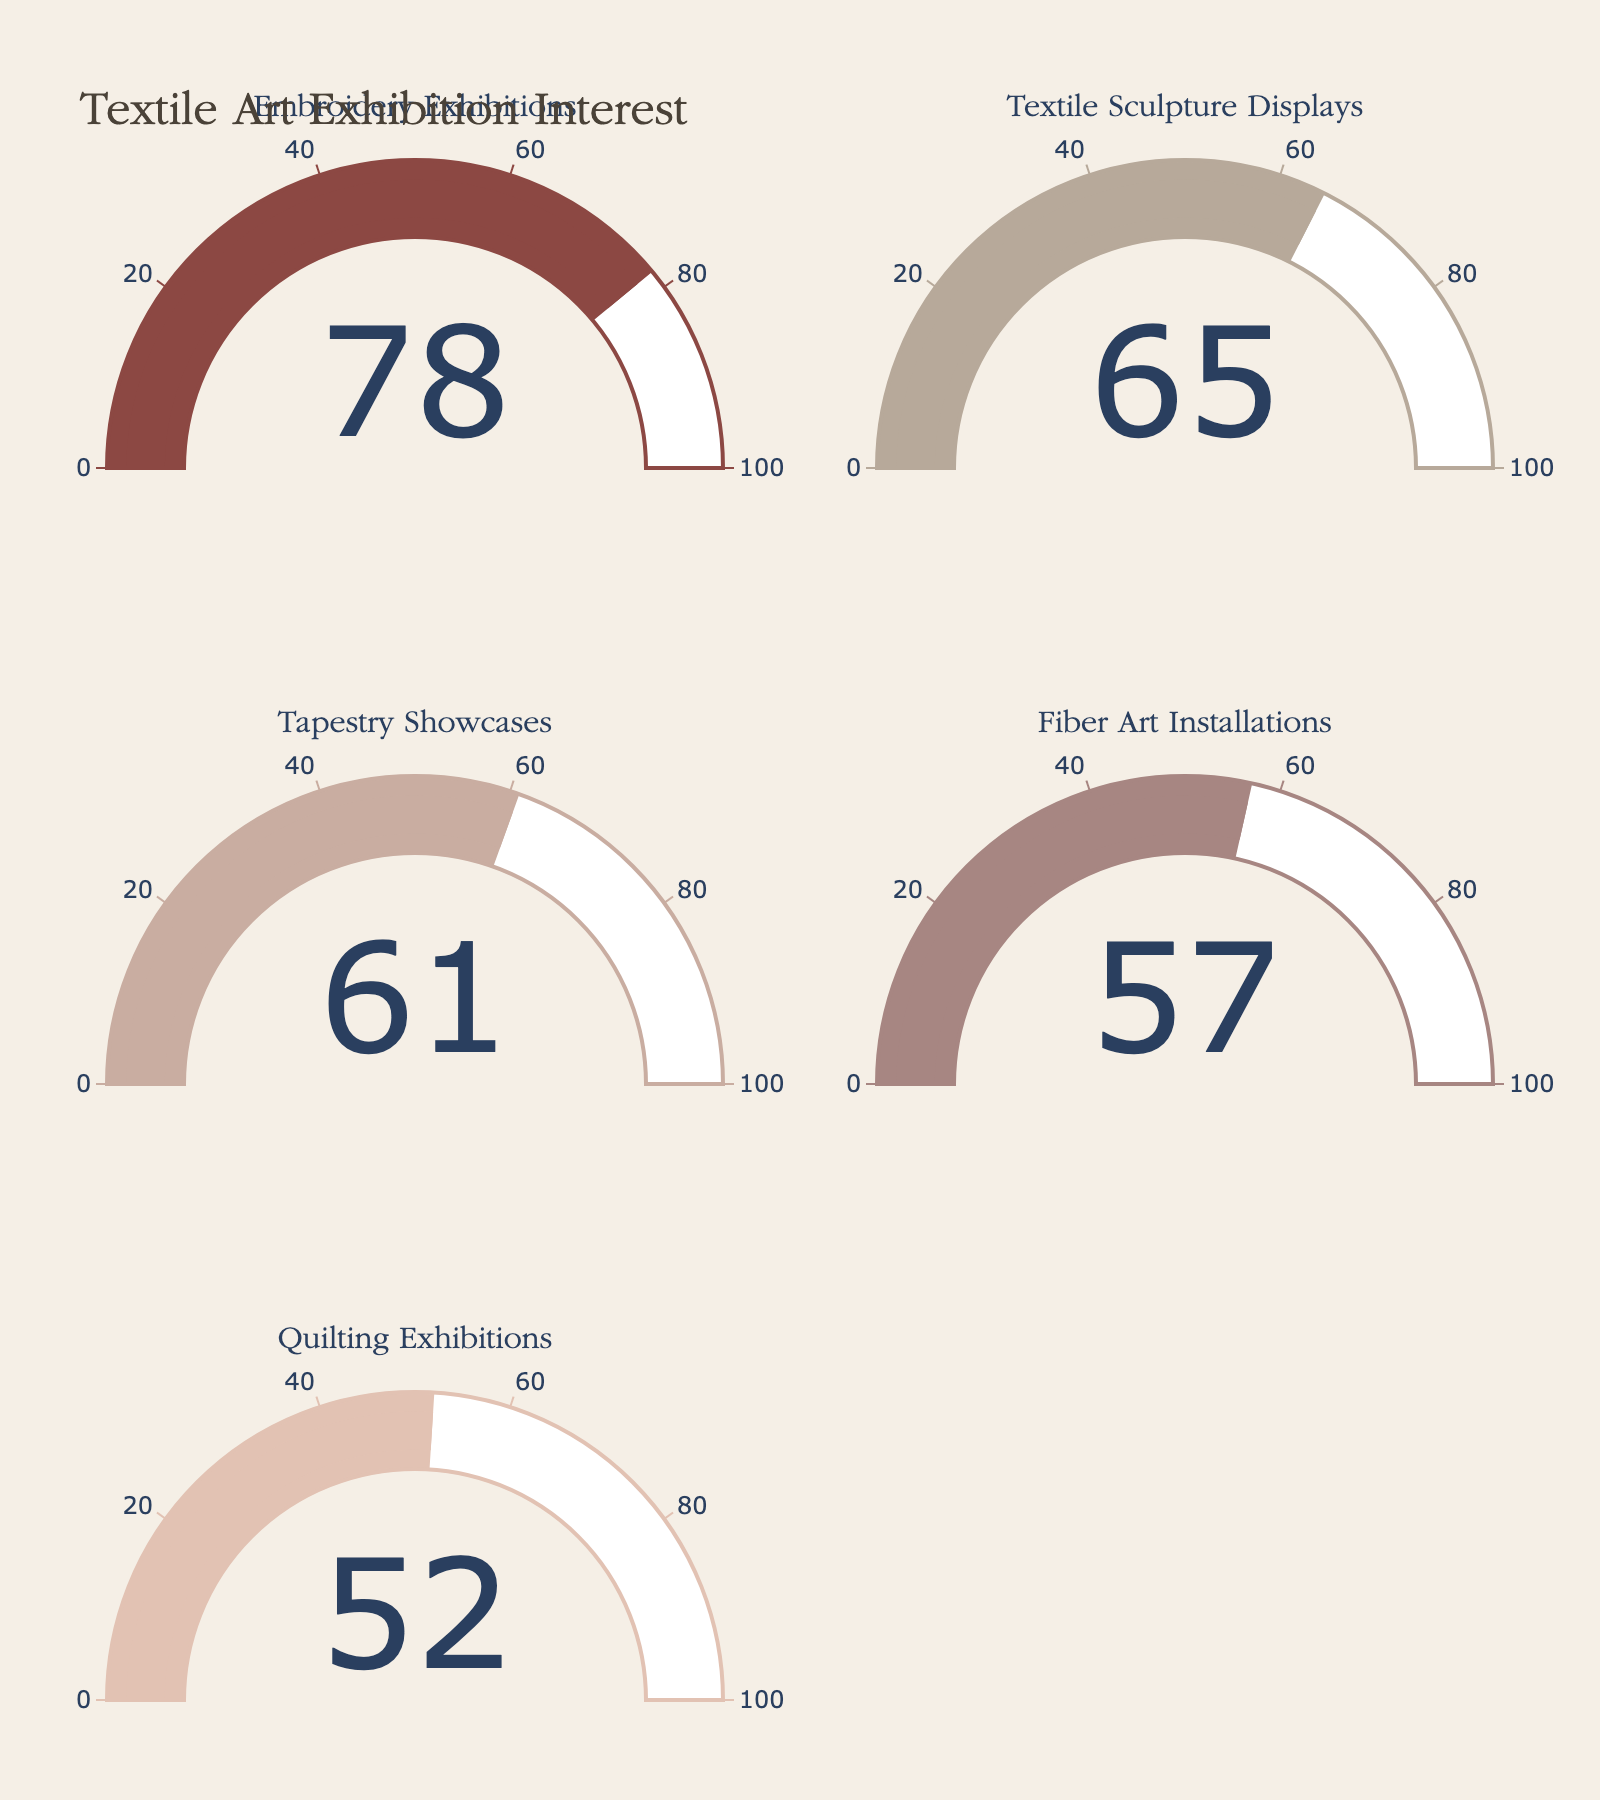what is the highest percentage displayed in the figure? Observing the gauges, the highest percentage shown is 78% for Embroidery Exhibitions.
Answer: 78% What categories are listed in the figure overall? The figure displays five categories: Embroidery Exhibitions, Textile Sculpture Displays, Tapestry Showcases, Fiber Art Installations, and Quilting Exhibitions.
Answer: 5 Which category has the lowest interest percentage? Analyzing the gauges, Quilting Exhibitions have the lowest interest at 52%.
Answer: Quilting Exhibitions What is the sum of all the percentages? Adding the five percentages: 78 + 65 + 61 + 57 + 52, the sum equals 313.
Answer: 313 What is the color of the gauge for Tapestry Showcases? The gauge for Tapestry Showcases uses a color inspired by textile art, which is specific to this category and appears as a muted tone.
Answer: muted tone How does Textile Sculpture Displays' interest compare with Fiber Art Installations? The percentage for Textile Sculpture Displays is 65%, while Fiber Art Installations is 57%. So, Textile Sculpture Displays have a higher interest.
Answer: higher What is the median interest percentage among the categories? Arranging the percentages in ascending order [52, 57, 61, 65, 78], the middle value is 61%, which is the median.
Answer: 61% Are there any categories with interest percentages above 50%? Each category's gauge shows percentages, all of which are above 50%.
Answer: Yes What do the percentages signify in this figure? The percentages displayed on the gauges represent the proportion of art gallery visitors interested in each type of textile art exhibition.
Answer: visitor interest Which gauge shows a percentage closest to the average percentage of all categories? The average is 313 / 5 = 62.6. The gauge closest to this is Tapestry Showcases at 61%.
Answer: Tapestry Showcases 